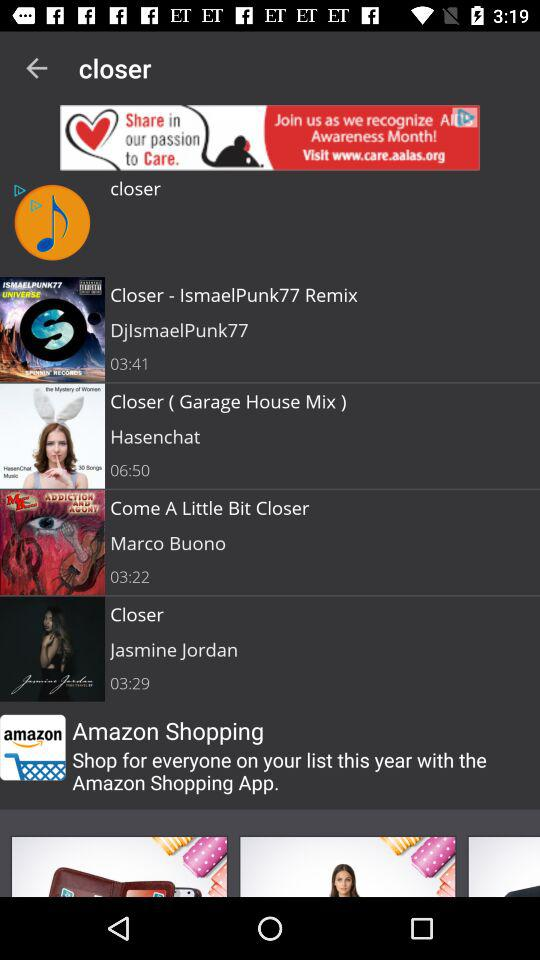Who sung the song "Come A Little Bit Closer"? It is sung by Marco Buono. 